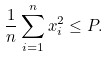Convert formula to latex. <formula><loc_0><loc_0><loc_500><loc_500>\frac { 1 } { n } \sum _ { i = 1 } ^ { n } x _ { i } ^ { 2 } \leq P .</formula> 